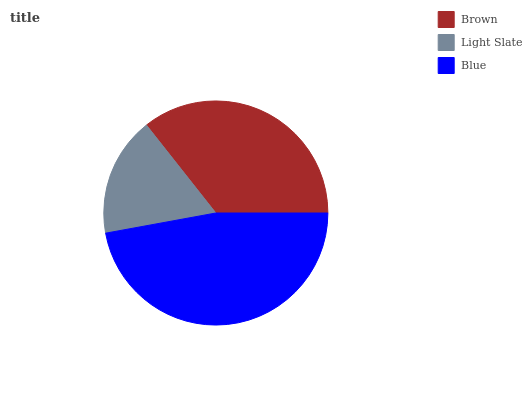Is Light Slate the minimum?
Answer yes or no. Yes. Is Blue the maximum?
Answer yes or no. Yes. Is Blue the minimum?
Answer yes or no. No. Is Light Slate the maximum?
Answer yes or no. No. Is Blue greater than Light Slate?
Answer yes or no. Yes. Is Light Slate less than Blue?
Answer yes or no. Yes. Is Light Slate greater than Blue?
Answer yes or no. No. Is Blue less than Light Slate?
Answer yes or no. No. Is Brown the high median?
Answer yes or no. Yes. Is Brown the low median?
Answer yes or no. Yes. Is Light Slate the high median?
Answer yes or no. No. Is Blue the low median?
Answer yes or no. No. 